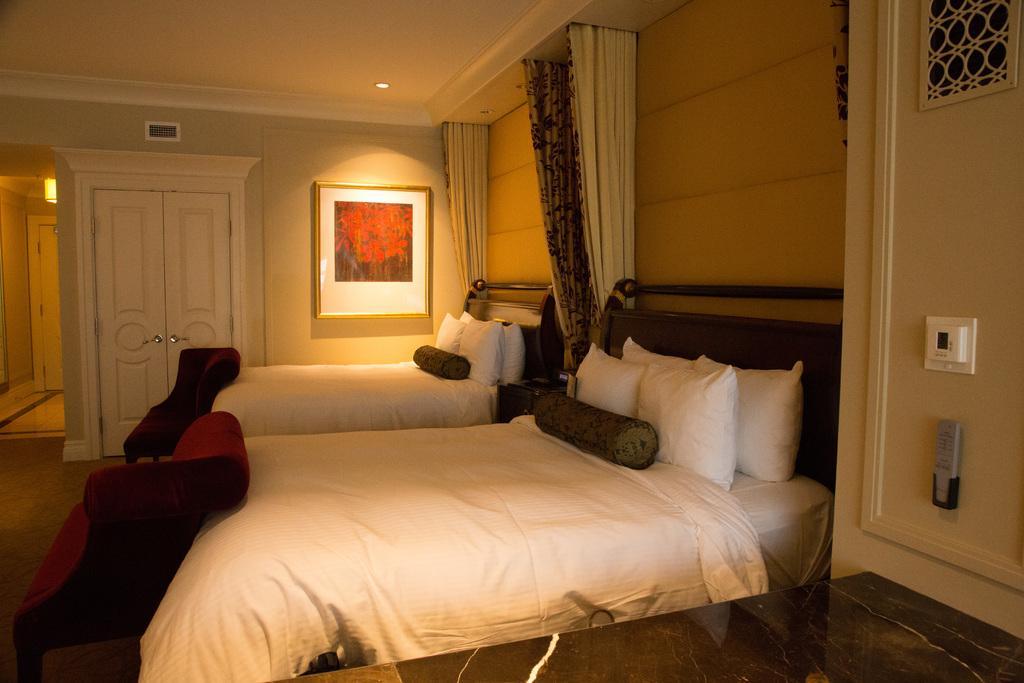Can you describe this image briefly? In this image I can see two beds. On the bed there are cushions and pillows. There is a frame attached to the wall. In this room I can also see the couch,curtains,light and the door. 